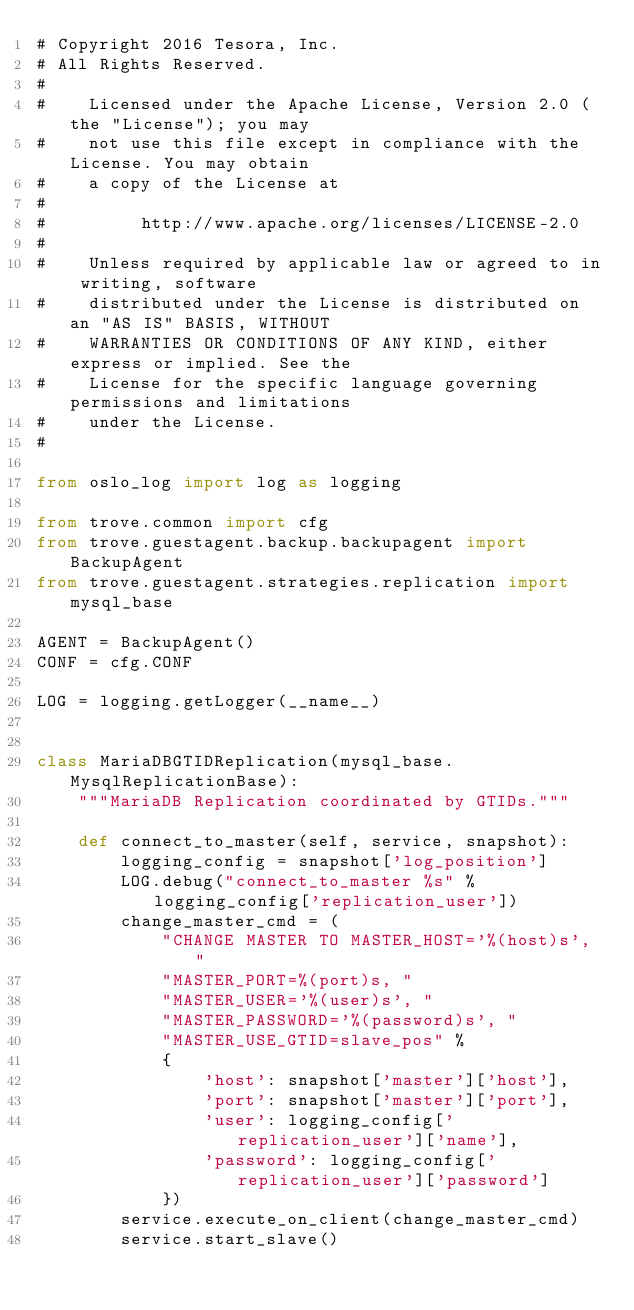Convert code to text. <code><loc_0><loc_0><loc_500><loc_500><_Python_># Copyright 2016 Tesora, Inc.
# All Rights Reserved.
#
#    Licensed under the Apache License, Version 2.0 (the "License"); you may
#    not use this file except in compliance with the License. You may obtain
#    a copy of the License at
#
#         http://www.apache.org/licenses/LICENSE-2.0
#
#    Unless required by applicable law or agreed to in writing, software
#    distributed under the License is distributed on an "AS IS" BASIS, WITHOUT
#    WARRANTIES OR CONDITIONS OF ANY KIND, either express or implied. See the
#    License for the specific language governing permissions and limitations
#    under the License.
#

from oslo_log import log as logging

from trove.common import cfg
from trove.guestagent.backup.backupagent import BackupAgent
from trove.guestagent.strategies.replication import mysql_base

AGENT = BackupAgent()
CONF = cfg.CONF

LOG = logging.getLogger(__name__)


class MariaDBGTIDReplication(mysql_base.MysqlReplicationBase):
    """MariaDB Replication coordinated by GTIDs."""

    def connect_to_master(self, service, snapshot):
        logging_config = snapshot['log_position']
        LOG.debug("connect_to_master %s" % logging_config['replication_user'])
        change_master_cmd = (
            "CHANGE MASTER TO MASTER_HOST='%(host)s', "
            "MASTER_PORT=%(port)s, "
            "MASTER_USER='%(user)s', "
            "MASTER_PASSWORD='%(password)s', "
            "MASTER_USE_GTID=slave_pos" %
            {
                'host': snapshot['master']['host'],
                'port': snapshot['master']['port'],
                'user': logging_config['replication_user']['name'],
                'password': logging_config['replication_user']['password']
            })
        service.execute_on_client(change_master_cmd)
        service.start_slave()
</code> 